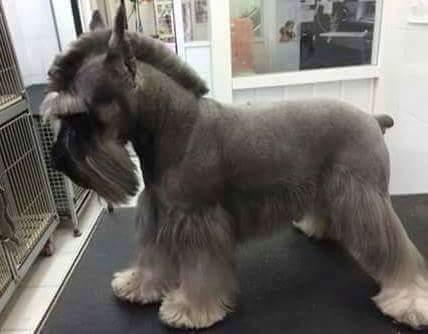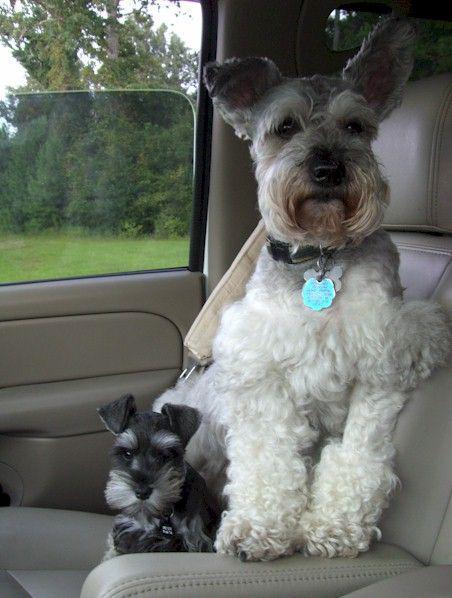The first image is the image on the left, the second image is the image on the right. Assess this claim about the two images: "In one image, a dog standing with legs straight and tail curled up is wearing a red collar.". Correct or not? Answer yes or no. No. 